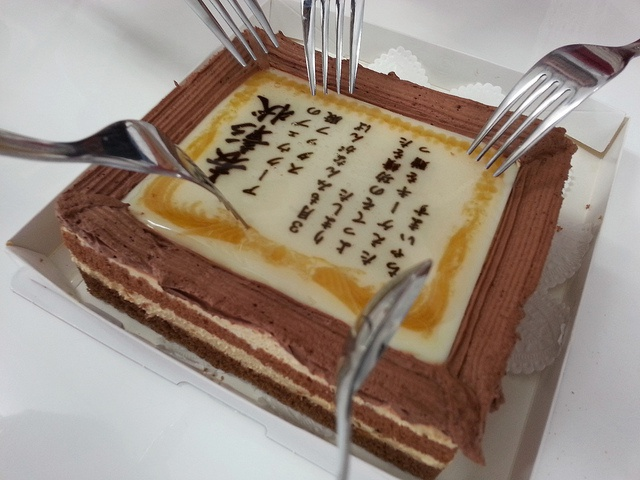Describe the objects in this image and their specific colors. I can see cake in lightgray, maroon, tan, and brown tones, dining table in lightgray and darkgray tones, fork in lightgray, darkgray, gray, and maroon tones, fork in lightgray, gray, black, darkgray, and brown tones, and fork in lightgray, gray, and darkgray tones in this image. 